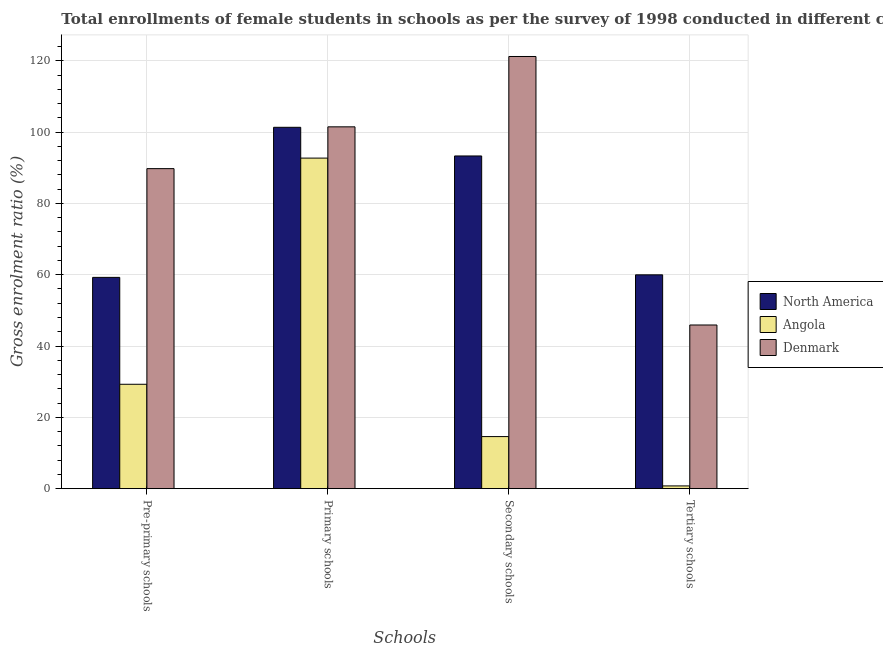How many different coloured bars are there?
Give a very brief answer. 3. Are the number of bars per tick equal to the number of legend labels?
Keep it short and to the point. Yes. Are the number of bars on each tick of the X-axis equal?
Your response must be concise. Yes. How many bars are there on the 2nd tick from the right?
Provide a succinct answer. 3. What is the label of the 2nd group of bars from the left?
Give a very brief answer. Primary schools. What is the gross enrolment ratio(female) in secondary schools in North America?
Your response must be concise. 93.31. Across all countries, what is the maximum gross enrolment ratio(female) in pre-primary schools?
Make the answer very short. 89.76. Across all countries, what is the minimum gross enrolment ratio(female) in secondary schools?
Provide a short and direct response. 14.61. In which country was the gross enrolment ratio(female) in secondary schools maximum?
Your answer should be very brief. Denmark. In which country was the gross enrolment ratio(female) in tertiary schools minimum?
Keep it short and to the point. Angola. What is the total gross enrolment ratio(female) in primary schools in the graph?
Offer a terse response. 295.53. What is the difference between the gross enrolment ratio(female) in tertiary schools in Angola and that in Denmark?
Your answer should be compact. -45.13. What is the difference between the gross enrolment ratio(female) in primary schools in Denmark and the gross enrolment ratio(female) in pre-primary schools in North America?
Your answer should be very brief. 42.22. What is the average gross enrolment ratio(female) in primary schools per country?
Provide a short and direct response. 98.51. What is the difference between the gross enrolment ratio(female) in tertiary schools and gross enrolment ratio(female) in secondary schools in Denmark?
Your answer should be very brief. -75.3. In how many countries, is the gross enrolment ratio(female) in secondary schools greater than 92 %?
Your response must be concise. 2. What is the ratio of the gross enrolment ratio(female) in tertiary schools in Angola to that in Denmark?
Your answer should be compact. 0.02. Is the difference between the gross enrolment ratio(female) in secondary schools in Angola and North America greater than the difference between the gross enrolment ratio(female) in tertiary schools in Angola and North America?
Offer a terse response. No. What is the difference between the highest and the second highest gross enrolment ratio(female) in primary schools?
Ensure brevity in your answer.  0.13. What is the difference between the highest and the lowest gross enrolment ratio(female) in primary schools?
Your response must be concise. 8.77. Is the sum of the gross enrolment ratio(female) in secondary schools in North America and Denmark greater than the maximum gross enrolment ratio(female) in primary schools across all countries?
Offer a terse response. Yes. Is it the case that in every country, the sum of the gross enrolment ratio(female) in pre-primary schools and gross enrolment ratio(female) in tertiary schools is greater than the sum of gross enrolment ratio(female) in primary schools and gross enrolment ratio(female) in secondary schools?
Offer a very short reply. No. What does the 2nd bar from the left in Tertiary schools represents?
Keep it short and to the point. Angola. What does the 1st bar from the right in Primary schools represents?
Your response must be concise. Denmark. How many bars are there?
Your answer should be very brief. 12. How many countries are there in the graph?
Make the answer very short. 3. What is the title of the graph?
Your answer should be compact. Total enrollments of female students in schools as per the survey of 1998 conducted in different countries. Does "Middle income" appear as one of the legend labels in the graph?
Provide a succinct answer. No. What is the label or title of the X-axis?
Keep it short and to the point. Schools. What is the label or title of the Y-axis?
Your response must be concise. Gross enrolment ratio (%). What is the Gross enrolment ratio (%) of North America in Pre-primary schools?
Your answer should be very brief. 59.26. What is the Gross enrolment ratio (%) in Angola in Pre-primary schools?
Your answer should be very brief. 29.28. What is the Gross enrolment ratio (%) in Denmark in Pre-primary schools?
Your answer should be compact. 89.76. What is the Gross enrolment ratio (%) of North America in Primary schools?
Make the answer very short. 101.35. What is the Gross enrolment ratio (%) in Angola in Primary schools?
Give a very brief answer. 92.71. What is the Gross enrolment ratio (%) in Denmark in Primary schools?
Provide a succinct answer. 101.48. What is the Gross enrolment ratio (%) of North America in Secondary schools?
Provide a short and direct response. 93.31. What is the Gross enrolment ratio (%) of Angola in Secondary schools?
Give a very brief answer. 14.61. What is the Gross enrolment ratio (%) in Denmark in Secondary schools?
Your answer should be very brief. 121.21. What is the Gross enrolment ratio (%) of North America in Tertiary schools?
Make the answer very short. 59.97. What is the Gross enrolment ratio (%) in Angola in Tertiary schools?
Provide a short and direct response. 0.77. What is the Gross enrolment ratio (%) in Denmark in Tertiary schools?
Make the answer very short. 45.9. Across all Schools, what is the maximum Gross enrolment ratio (%) of North America?
Your response must be concise. 101.35. Across all Schools, what is the maximum Gross enrolment ratio (%) of Angola?
Offer a terse response. 92.71. Across all Schools, what is the maximum Gross enrolment ratio (%) in Denmark?
Your answer should be very brief. 121.21. Across all Schools, what is the minimum Gross enrolment ratio (%) of North America?
Offer a very short reply. 59.26. Across all Schools, what is the minimum Gross enrolment ratio (%) of Angola?
Your answer should be very brief. 0.77. Across all Schools, what is the minimum Gross enrolment ratio (%) in Denmark?
Keep it short and to the point. 45.9. What is the total Gross enrolment ratio (%) in North America in the graph?
Your answer should be very brief. 313.88. What is the total Gross enrolment ratio (%) of Angola in the graph?
Offer a terse response. 137.37. What is the total Gross enrolment ratio (%) of Denmark in the graph?
Offer a very short reply. 358.35. What is the difference between the Gross enrolment ratio (%) in North America in Pre-primary schools and that in Primary schools?
Keep it short and to the point. -42.09. What is the difference between the Gross enrolment ratio (%) of Angola in Pre-primary schools and that in Primary schools?
Keep it short and to the point. -63.43. What is the difference between the Gross enrolment ratio (%) in Denmark in Pre-primary schools and that in Primary schools?
Your answer should be compact. -11.72. What is the difference between the Gross enrolment ratio (%) of North America in Pre-primary schools and that in Secondary schools?
Offer a terse response. -34.05. What is the difference between the Gross enrolment ratio (%) of Angola in Pre-primary schools and that in Secondary schools?
Give a very brief answer. 14.67. What is the difference between the Gross enrolment ratio (%) in Denmark in Pre-primary schools and that in Secondary schools?
Make the answer very short. -31.45. What is the difference between the Gross enrolment ratio (%) in North America in Pre-primary schools and that in Tertiary schools?
Your response must be concise. -0.72. What is the difference between the Gross enrolment ratio (%) in Angola in Pre-primary schools and that in Tertiary schools?
Provide a succinct answer. 28.5. What is the difference between the Gross enrolment ratio (%) in Denmark in Pre-primary schools and that in Tertiary schools?
Give a very brief answer. 43.85. What is the difference between the Gross enrolment ratio (%) of North America in Primary schools and that in Secondary schools?
Offer a very short reply. 8.04. What is the difference between the Gross enrolment ratio (%) of Angola in Primary schools and that in Secondary schools?
Provide a succinct answer. 78.1. What is the difference between the Gross enrolment ratio (%) of Denmark in Primary schools and that in Secondary schools?
Your answer should be compact. -19.73. What is the difference between the Gross enrolment ratio (%) of North America in Primary schools and that in Tertiary schools?
Make the answer very short. 41.37. What is the difference between the Gross enrolment ratio (%) in Angola in Primary schools and that in Tertiary schools?
Make the answer very short. 91.93. What is the difference between the Gross enrolment ratio (%) of Denmark in Primary schools and that in Tertiary schools?
Keep it short and to the point. 55.57. What is the difference between the Gross enrolment ratio (%) of North America in Secondary schools and that in Tertiary schools?
Make the answer very short. 33.34. What is the difference between the Gross enrolment ratio (%) in Angola in Secondary schools and that in Tertiary schools?
Your response must be concise. 13.83. What is the difference between the Gross enrolment ratio (%) in Denmark in Secondary schools and that in Tertiary schools?
Offer a very short reply. 75.3. What is the difference between the Gross enrolment ratio (%) of North America in Pre-primary schools and the Gross enrolment ratio (%) of Angola in Primary schools?
Offer a very short reply. -33.45. What is the difference between the Gross enrolment ratio (%) of North America in Pre-primary schools and the Gross enrolment ratio (%) of Denmark in Primary schools?
Your response must be concise. -42.22. What is the difference between the Gross enrolment ratio (%) in Angola in Pre-primary schools and the Gross enrolment ratio (%) in Denmark in Primary schools?
Offer a very short reply. -72.2. What is the difference between the Gross enrolment ratio (%) in North America in Pre-primary schools and the Gross enrolment ratio (%) in Angola in Secondary schools?
Your answer should be compact. 44.65. What is the difference between the Gross enrolment ratio (%) of North America in Pre-primary schools and the Gross enrolment ratio (%) of Denmark in Secondary schools?
Provide a short and direct response. -61.95. What is the difference between the Gross enrolment ratio (%) of Angola in Pre-primary schools and the Gross enrolment ratio (%) of Denmark in Secondary schools?
Your answer should be very brief. -91.93. What is the difference between the Gross enrolment ratio (%) of North America in Pre-primary schools and the Gross enrolment ratio (%) of Angola in Tertiary schools?
Provide a short and direct response. 58.48. What is the difference between the Gross enrolment ratio (%) in North America in Pre-primary schools and the Gross enrolment ratio (%) in Denmark in Tertiary schools?
Make the answer very short. 13.35. What is the difference between the Gross enrolment ratio (%) in Angola in Pre-primary schools and the Gross enrolment ratio (%) in Denmark in Tertiary schools?
Ensure brevity in your answer.  -16.63. What is the difference between the Gross enrolment ratio (%) in North America in Primary schools and the Gross enrolment ratio (%) in Angola in Secondary schools?
Your answer should be very brief. 86.74. What is the difference between the Gross enrolment ratio (%) of North America in Primary schools and the Gross enrolment ratio (%) of Denmark in Secondary schools?
Make the answer very short. -19.86. What is the difference between the Gross enrolment ratio (%) of Angola in Primary schools and the Gross enrolment ratio (%) of Denmark in Secondary schools?
Offer a very short reply. -28.5. What is the difference between the Gross enrolment ratio (%) of North America in Primary schools and the Gross enrolment ratio (%) of Angola in Tertiary schools?
Ensure brevity in your answer.  100.57. What is the difference between the Gross enrolment ratio (%) in North America in Primary schools and the Gross enrolment ratio (%) in Denmark in Tertiary schools?
Provide a succinct answer. 55.44. What is the difference between the Gross enrolment ratio (%) of Angola in Primary schools and the Gross enrolment ratio (%) of Denmark in Tertiary schools?
Offer a terse response. 46.8. What is the difference between the Gross enrolment ratio (%) of North America in Secondary schools and the Gross enrolment ratio (%) of Angola in Tertiary schools?
Make the answer very short. 92.53. What is the difference between the Gross enrolment ratio (%) of North America in Secondary schools and the Gross enrolment ratio (%) of Denmark in Tertiary schools?
Give a very brief answer. 47.4. What is the difference between the Gross enrolment ratio (%) of Angola in Secondary schools and the Gross enrolment ratio (%) of Denmark in Tertiary schools?
Offer a very short reply. -31.3. What is the average Gross enrolment ratio (%) in North America per Schools?
Your response must be concise. 78.47. What is the average Gross enrolment ratio (%) in Angola per Schools?
Offer a very short reply. 34.34. What is the average Gross enrolment ratio (%) in Denmark per Schools?
Offer a terse response. 89.59. What is the difference between the Gross enrolment ratio (%) in North America and Gross enrolment ratio (%) in Angola in Pre-primary schools?
Give a very brief answer. 29.98. What is the difference between the Gross enrolment ratio (%) in North America and Gross enrolment ratio (%) in Denmark in Pre-primary schools?
Provide a short and direct response. -30.5. What is the difference between the Gross enrolment ratio (%) in Angola and Gross enrolment ratio (%) in Denmark in Pre-primary schools?
Provide a succinct answer. -60.48. What is the difference between the Gross enrolment ratio (%) of North America and Gross enrolment ratio (%) of Angola in Primary schools?
Your answer should be very brief. 8.64. What is the difference between the Gross enrolment ratio (%) of North America and Gross enrolment ratio (%) of Denmark in Primary schools?
Offer a very short reply. -0.13. What is the difference between the Gross enrolment ratio (%) of Angola and Gross enrolment ratio (%) of Denmark in Primary schools?
Keep it short and to the point. -8.77. What is the difference between the Gross enrolment ratio (%) in North America and Gross enrolment ratio (%) in Angola in Secondary schools?
Provide a succinct answer. 78.7. What is the difference between the Gross enrolment ratio (%) in North America and Gross enrolment ratio (%) in Denmark in Secondary schools?
Your answer should be compact. -27.9. What is the difference between the Gross enrolment ratio (%) in Angola and Gross enrolment ratio (%) in Denmark in Secondary schools?
Offer a terse response. -106.6. What is the difference between the Gross enrolment ratio (%) in North America and Gross enrolment ratio (%) in Angola in Tertiary schools?
Your answer should be compact. 59.2. What is the difference between the Gross enrolment ratio (%) of North America and Gross enrolment ratio (%) of Denmark in Tertiary schools?
Give a very brief answer. 14.07. What is the difference between the Gross enrolment ratio (%) of Angola and Gross enrolment ratio (%) of Denmark in Tertiary schools?
Your answer should be compact. -45.13. What is the ratio of the Gross enrolment ratio (%) of North America in Pre-primary schools to that in Primary schools?
Provide a succinct answer. 0.58. What is the ratio of the Gross enrolment ratio (%) of Angola in Pre-primary schools to that in Primary schools?
Offer a very short reply. 0.32. What is the ratio of the Gross enrolment ratio (%) of Denmark in Pre-primary schools to that in Primary schools?
Provide a succinct answer. 0.88. What is the ratio of the Gross enrolment ratio (%) of North America in Pre-primary schools to that in Secondary schools?
Offer a terse response. 0.64. What is the ratio of the Gross enrolment ratio (%) of Angola in Pre-primary schools to that in Secondary schools?
Ensure brevity in your answer.  2. What is the ratio of the Gross enrolment ratio (%) in Denmark in Pre-primary schools to that in Secondary schools?
Keep it short and to the point. 0.74. What is the ratio of the Gross enrolment ratio (%) in Angola in Pre-primary schools to that in Tertiary schools?
Provide a short and direct response. 37.79. What is the ratio of the Gross enrolment ratio (%) of Denmark in Pre-primary schools to that in Tertiary schools?
Your response must be concise. 1.96. What is the ratio of the Gross enrolment ratio (%) in North America in Primary schools to that in Secondary schools?
Your answer should be very brief. 1.09. What is the ratio of the Gross enrolment ratio (%) in Angola in Primary schools to that in Secondary schools?
Offer a terse response. 6.35. What is the ratio of the Gross enrolment ratio (%) in Denmark in Primary schools to that in Secondary schools?
Your answer should be compact. 0.84. What is the ratio of the Gross enrolment ratio (%) in North America in Primary schools to that in Tertiary schools?
Your response must be concise. 1.69. What is the ratio of the Gross enrolment ratio (%) of Angola in Primary schools to that in Tertiary schools?
Your answer should be very brief. 119.67. What is the ratio of the Gross enrolment ratio (%) in Denmark in Primary schools to that in Tertiary schools?
Offer a terse response. 2.21. What is the ratio of the Gross enrolment ratio (%) in North America in Secondary schools to that in Tertiary schools?
Ensure brevity in your answer.  1.56. What is the ratio of the Gross enrolment ratio (%) of Angola in Secondary schools to that in Tertiary schools?
Offer a very short reply. 18.86. What is the ratio of the Gross enrolment ratio (%) in Denmark in Secondary schools to that in Tertiary schools?
Your response must be concise. 2.64. What is the difference between the highest and the second highest Gross enrolment ratio (%) in North America?
Offer a terse response. 8.04. What is the difference between the highest and the second highest Gross enrolment ratio (%) in Angola?
Your answer should be very brief. 63.43. What is the difference between the highest and the second highest Gross enrolment ratio (%) of Denmark?
Provide a short and direct response. 19.73. What is the difference between the highest and the lowest Gross enrolment ratio (%) in North America?
Your answer should be compact. 42.09. What is the difference between the highest and the lowest Gross enrolment ratio (%) of Angola?
Make the answer very short. 91.93. What is the difference between the highest and the lowest Gross enrolment ratio (%) of Denmark?
Make the answer very short. 75.3. 